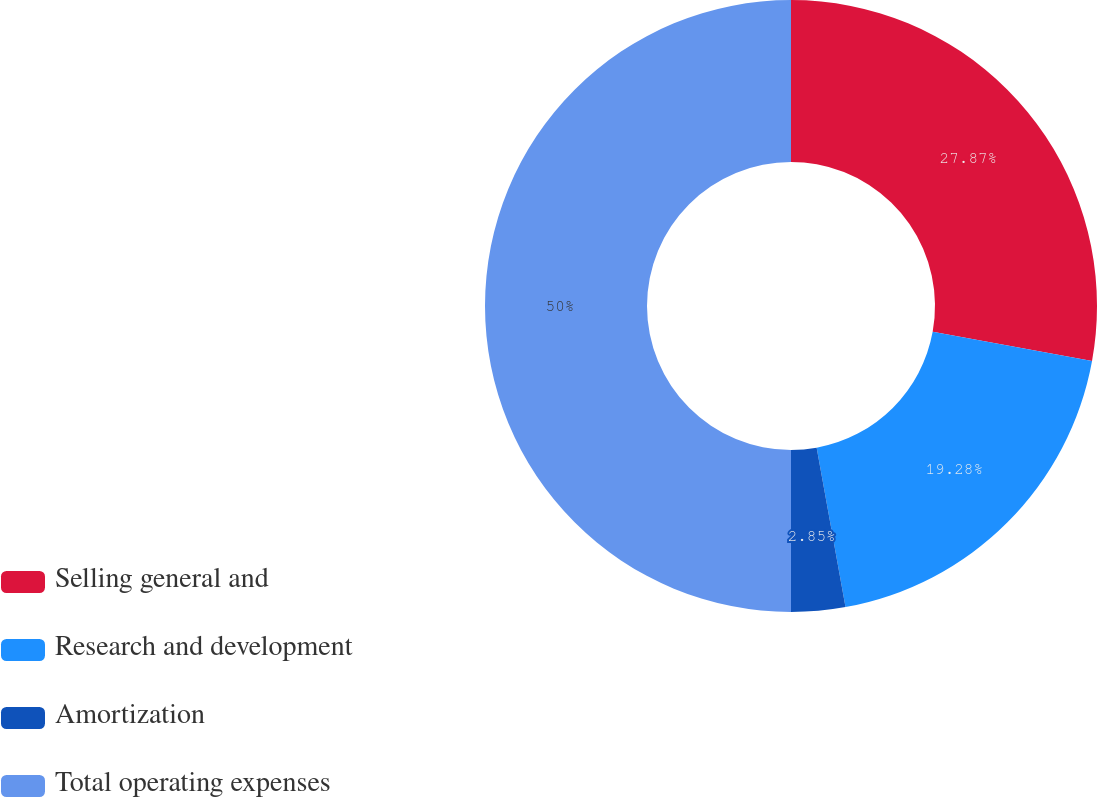Convert chart. <chart><loc_0><loc_0><loc_500><loc_500><pie_chart><fcel>Selling general and<fcel>Research and development<fcel>Amortization<fcel>Total operating expenses<nl><fcel>27.87%<fcel>19.28%<fcel>2.85%<fcel>50.0%<nl></chart> 